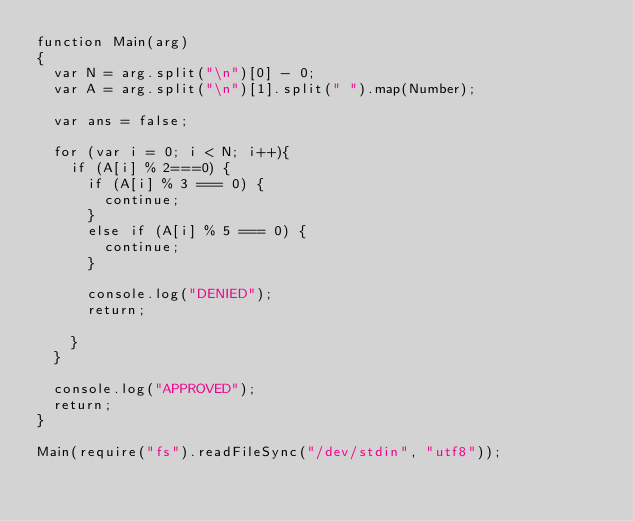<code> <loc_0><loc_0><loc_500><loc_500><_JavaScript_>function Main(arg)
{
  var N = arg.split("\n")[0] - 0;
  var A = arg.split("\n")[1].split(" ").map(Number);
  
  var ans = false;

  for (var i = 0; i < N; i++){
    if (A[i] % 2===0) {
      if (A[i] % 3 === 0) {
        continue;
      }
      else if (A[i] % 5 === 0) {
        continue;
      }

      console.log("DENIED");
      return;

    }
  }

  console.log("APPROVED");
  return;
}

Main(require("fs").readFileSync("/dev/stdin", "utf8"));</code> 